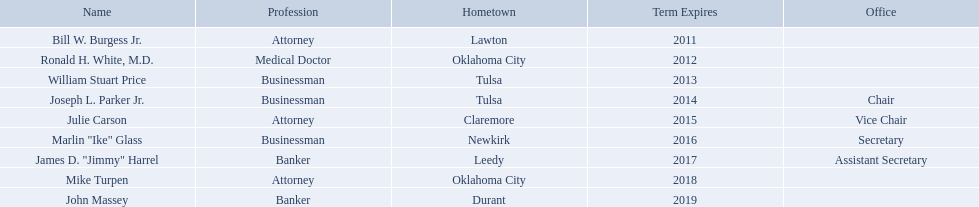Who are the regents? Bill W. Burgess Jr., Ronald H. White, M.D., William Stuart Price, Joseph L. Parker Jr., Julie Carson, Marlin "Ike" Glass, James D. "Jimmy" Harrel, Mike Turpen, John Massey. Of these who is a businessman? William Stuart Price, Joseph L. Parker Jr., Marlin "Ike" Glass. Of these whose hometown is tulsa? William Stuart Price, Joseph L. Parker Jr. Of these whose term expires in 2013? William Stuart Price. Who are the businessmen? Bill W. Burgess Jr., Ronald H. White, M.D., William Stuart Price, Joseph L. Parker Jr., Julie Carson, Marlin "Ike" Glass, James D. "Jimmy" Harrel, Mike Turpen, John Massey. Which were born in tulsa? William Stuart Price, Joseph L. Parker Jr. Of these, which one was other than william stuart price? Joseph L. Parker Jr. What are the names of the oklahoma state regents for higher education? Bill W. Burgess Jr., Ronald H. White, M.D., William Stuart Price, Joseph L. Parker Jr., Julie Carson, Marlin "Ike" Glass, James D. "Jimmy" Harrel, Mike Turpen, John Massey. What is ronald h. white's hometown? Oklahoma City. Which other regent has the same hometown as above? Mike Turpen. Which entrepreneurs were born in tulsa? William Stuart Price, Joseph L. Parker Jr. Which individual, besides price, was born in tulsa? Joseph L. Parker Jr. Can you give me this table in json format? {'header': ['Name', 'Profession', 'Hometown', 'Term Expires', 'Office'], 'rows': [['Bill W. Burgess Jr.', 'Attorney', 'Lawton', '2011', ''], ['Ronald H. White, M.D.', 'Medical Doctor', 'Oklahoma City', '2012', ''], ['William Stuart Price', 'Businessman', 'Tulsa', '2013', ''], ['Joseph L. Parker Jr.', 'Businessman', 'Tulsa', '2014', 'Chair'], ['Julie Carson', 'Attorney', 'Claremore', '2015', 'Vice Chair'], ['Marlin "Ike" Glass', 'Businessman', 'Newkirk', '2016', 'Secretary'], ['James D. "Jimmy" Harrel', 'Banker', 'Leedy', '2017', 'Assistant Secretary'], ['Mike Turpen', 'Attorney', 'Oklahoma City', '2018', ''], ['John Massey', 'Banker', 'Durant', '2019', '']]} Who are the state supervisors? Bill W. Burgess Jr., Ronald H. White, M.D., William Stuart Price, Joseph L. Parker Jr., Julie Carson, Marlin "Ike" Glass, James D. "Jimmy" Harrel, Mike Turpen, John Massey. Among those state supervisors, who is from the same native town as ronald h. white, m.d.? Mike Turpen. What are the designations of the oklahoma state regents for higher learning? Bill W. Burgess Jr., Ronald H. White, M.D., William Stuart Price, Joseph L. Parker Jr., Julie Carson, Marlin "Ike" Glass, James D. "Jimmy" Harrel, Mike Turpen, John Massey. What is ronald h. white's place of origin? Oklahoma City. Which other board member has the same hometown as previously mentioned? Mike Turpen. What are the complete names of oklahoma state regents for higher learning? Bill W. Burgess Jr., Ronald H. White, M.D., William Stuart Price, Joseph L. Parker Jr., Julie Carson, Marlin "Ike" Glass, James D. "Jimmy" Harrel, Mike Turpen, John Massey. Which ones are entrepreneurs? William Stuart Price, Joseph L. Parker Jr., Marlin "Ike" Glass. Among them, who hails from tulsa? William Stuart Price, Joseph L. Parker Jr. Whose tenure concludes in 2014? Joseph L. Parker Jr. Which commercial figures were birthed in tulsa? William Stuart Price, Joseph L. Parker Jr. Excluding price, who else was born in tulsa? Joseph L. Parker Jr. Which regents originate from tulsa? William Stuart Price, Joseph L. Parker Jr. Which among these is not joseph parker, jr.? William Stuart Price. Could you help me parse every detail presented in this table? {'header': ['Name', 'Profession', 'Hometown', 'Term Expires', 'Office'], 'rows': [['Bill W. Burgess Jr.', 'Attorney', 'Lawton', '2011', ''], ['Ronald H. White, M.D.', 'Medical Doctor', 'Oklahoma City', '2012', ''], ['William Stuart Price', 'Businessman', 'Tulsa', '2013', ''], ['Joseph L. Parker Jr.', 'Businessman', 'Tulsa', '2014', 'Chair'], ['Julie Carson', 'Attorney', 'Claremore', '2015', 'Vice Chair'], ['Marlin "Ike" Glass', 'Businessman', 'Newkirk', '2016', 'Secretary'], ['James D. "Jimmy" Harrel', 'Banker', 'Leedy', '2017', 'Assistant Secretary'], ['Mike Turpen', 'Attorney', 'Oklahoma City', '2018', ''], ['John Massey', 'Banker', 'Durant', '2019', '']]} Can you list the regents? Bill W. Burgess Jr., Ronald H. White, M.D., William Stuart Price, Joseph L. Parker Jr., Julie Carson, Marlin "Ike" Glass, James D. "Jimmy" Harrel, Mike Turpen, John Massey. Could you parse the entire table as a dict? {'header': ['Name', 'Profession', 'Hometown', 'Term Expires', 'Office'], 'rows': [['Bill W. Burgess Jr.', 'Attorney', 'Lawton', '2011', ''], ['Ronald H. White, M.D.', 'Medical Doctor', 'Oklahoma City', '2012', ''], ['William Stuart Price', 'Businessman', 'Tulsa', '2013', ''], ['Joseph L. Parker Jr.', 'Businessman', 'Tulsa', '2014', 'Chair'], ['Julie Carson', 'Attorney', 'Claremore', '2015', 'Vice Chair'], ['Marlin "Ike" Glass', 'Businessman', 'Newkirk', '2016', 'Secretary'], ['James D. "Jimmy" Harrel', 'Banker', 'Leedy', '2017', 'Assistant Secretary'], ['Mike Turpen', 'Attorney', 'Oklahoma City', '2018', ''], ['John Massey', 'Banker', 'Durant', '2019', '']]} From this list, who has a career in business? William Stuart Price, Joseph L. Parker Jr., Marlin "Ike" Glass. Among them, who is from tulsa? William Stuart Price, Joseph L. Parker Jr. Additionally, who had their term expire in 2013? William Stuart Price. What is the hometown of bill w. burgess jr.? Lawton. What is the origin of price and parker? Tulsa. Who hails from the same state as white? Mike Turpen. In which location was bill w. burgess jr. born? Lawton. Where do price and parker originate? Tulsa. Who has the same state of origin as white? Mike Turpen. What are the identities of the oklahoma state regents for higher education? Bill W. Burgess Jr., Ronald H. White, M.D., William Stuart Price, Joseph L. Parker Jr., Julie Carson, Marlin "Ike" Glass, James D. "Jimmy" Harrel, Mike Turpen, John Massey. What is the birthplace of ronald h. white? Oklahoma City. Is there another regent sharing the same hometown as ronald h. white? Mike Turpen. Can you provide the names of the oklahoma state regents responsible for higher education? Bill W. Burgess Jr., Ronald H. White, M.D., William Stuart Price, Joseph L. Parker Jr., Julie Carson, Marlin "Ike" Glass, James D. "Jimmy" Harrel, Mike Turpen, John Massey. Which town does ronald h. white come from? Oklahoma City. Does any other regent originate from the same town as him? Mike Turpen. 